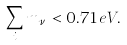<formula> <loc_0><loc_0><loc_500><loc_500>\sum _ { i } m _ { \nu _ { i } } < 0 . 7 1 \, e V .</formula> 